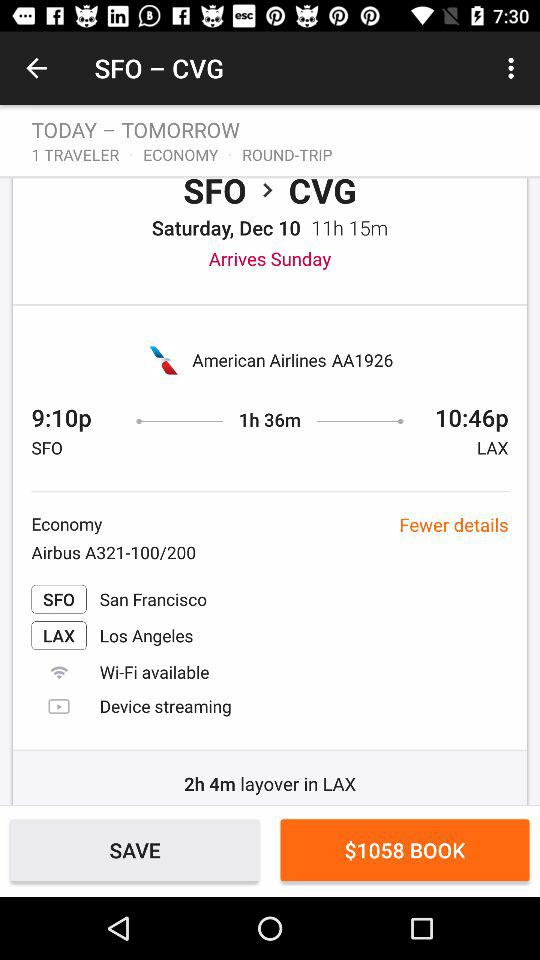What is the journey time between the SFO and LAX airports? The journey time is 1 hour 36 minutes. 